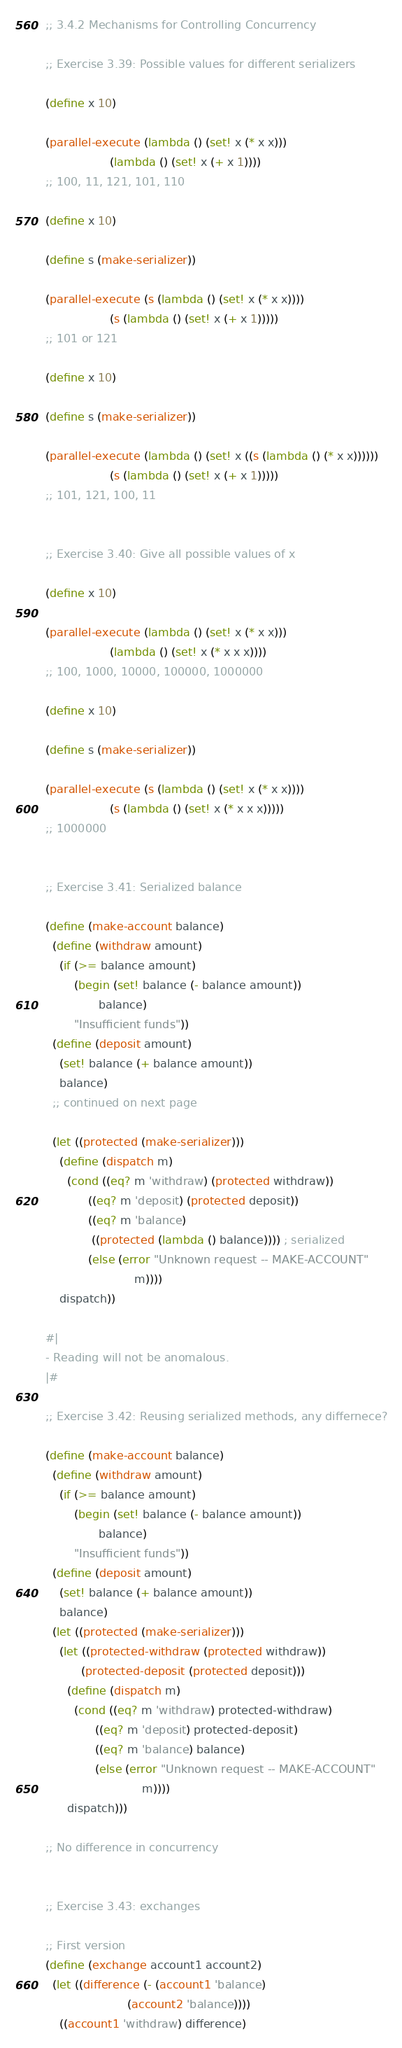Convert code to text. <code><loc_0><loc_0><loc_500><loc_500><_Scheme_>;; 3.4.2 Mechanisms for Controlling Concurrency

;; Exercise 3.39: Possible values for different serializers

(define x 10)

(parallel-execute (lambda () (set! x (* x x)))
                  (lambda () (set! x (+ x 1))))
;; 100, 11, 121, 101, 110

(define x 10)

(define s (make-serializer))

(parallel-execute (s (lambda () (set! x (* x x))))
                  (s (lambda () (set! x (+ x 1)))))
;; 101 or 121

(define x 10)

(define s (make-serializer))

(parallel-execute (lambda () (set! x ((s (lambda () (* x x))))))
                  (s (lambda () (set! x (+ x 1)))))
;; 101, 121, 100, 11


;; Exercise 3.40: Give all possible values of x

(define x 10)

(parallel-execute (lambda () (set! x (* x x)))
                  (lambda () (set! x (* x x x))))
;; 100, 1000, 10000, 100000, 1000000

(define x 10)

(define s (make-serializer))

(parallel-execute (s (lambda () (set! x (* x x))))
                  (s (lambda () (set! x (* x x x)))))
;; 1000000


;; Exercise 3.41: Serialized balance

(define (make-account balance)
  (define (withdraw amount)
    (if (>= balance amount)
        (begin (set! balance (- balance amount))
               balance)
        "Insufficient funds"))
  (define (deposit amount)
    (set! balance (+ balance amount))
    balance)
  ;; continued on next page

  (let ((protected (make-serializer)))
    (define (dispatch m)
      (cond ((eq? m 'withdraw) (protected withdraw))
            ((eq? m 'deposit) (protected deposit))
            ((eq? m 'balance)
             ((protected (lambda () balance)))) ; serialized
            (else (error "Unknown request -- MAKE-ACCOUNT"
                         m))))
    dispatch))

#| 
- Reading will not be anomalous.
|#

;; Exercise 3.42: Reusing serialized methods, any differnece?

(define (make-account balance)
  (define (withdraw amount)
    (if (>= balance amount)
        (begin (set! balance (- balance amount))
               balance)
        "Insufficient funds"))
  (define (deposit amount)
    (set! balance (+ balance amount))
    balance)
  (let ((protected (make-serializer)))
    (let ((protected-withdraw (protected withdraw))
          (protected-deposit (protected deposit)))
      (define (dispatch m)
        (cond ((eq? m 'withdraw) protected-withdraw)
              ((eq? m 'deposit) protected-deposit)
              ((eq? m 'balance) balance)
              (else (error "Unknown request -- MAKE-ACCOUNT"
                           m))))
      dispatch)))

;; No difference in concurrency


;; Exercise 3.43: exchanges

;; First version
(define (exchange account1 account2)
  (let ((difference (- (account1 'balance)
                       (account2 'balance))))
    ((account1 'withdraw) difference)</code> 